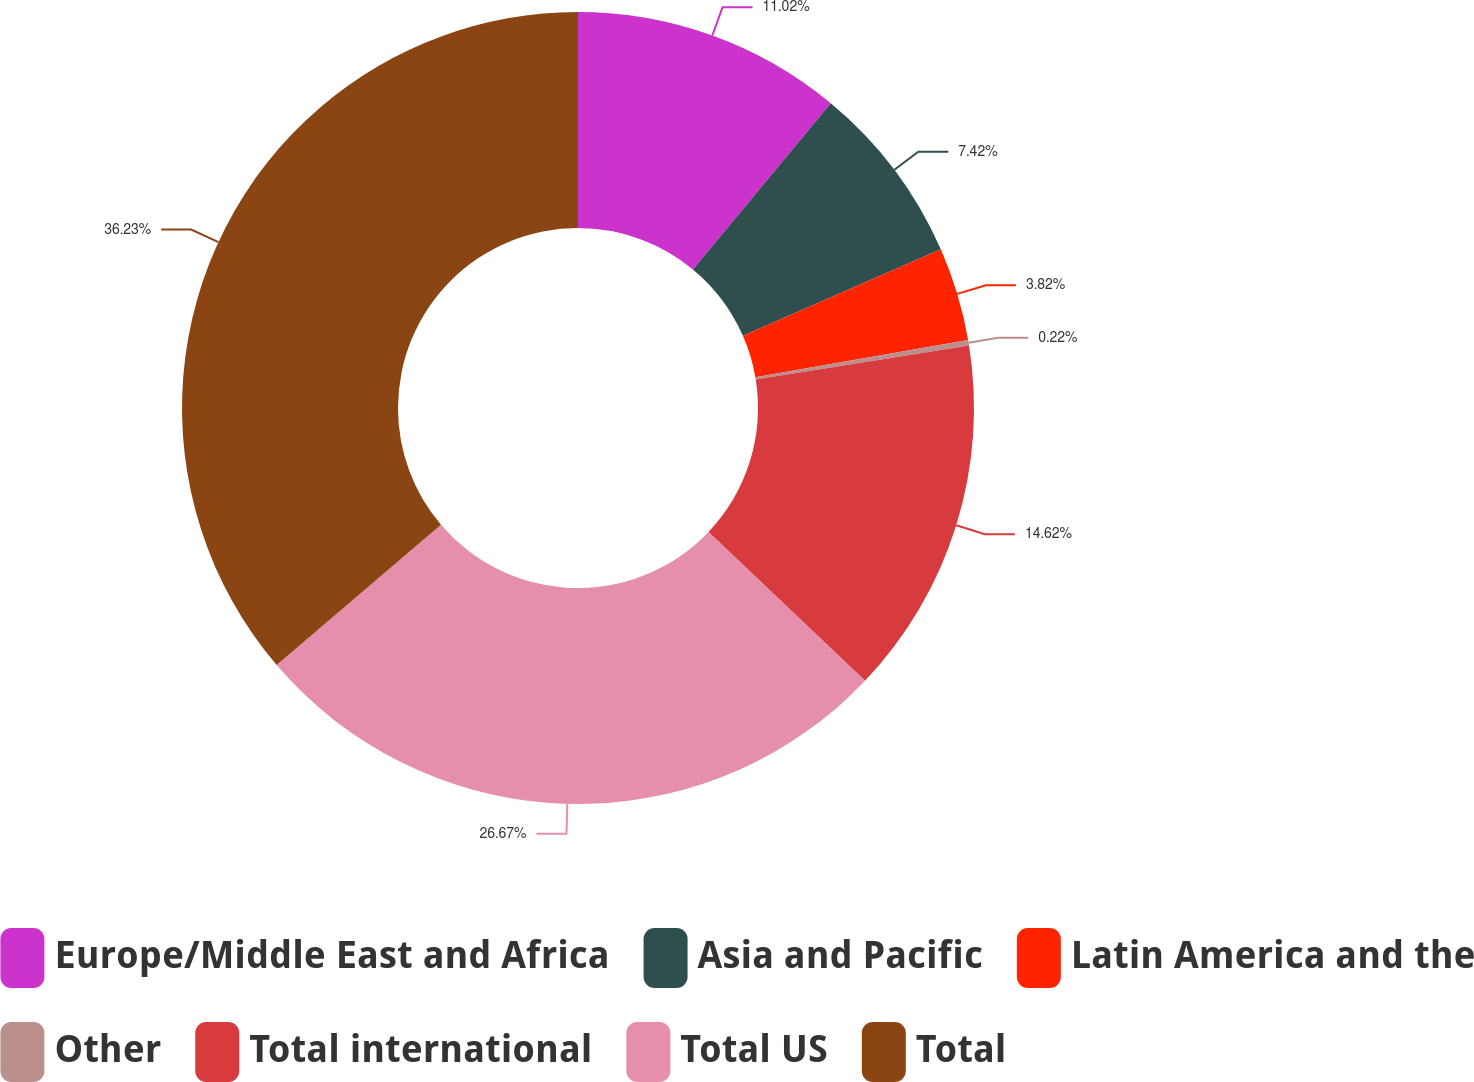<chart> <loc_0><loc_0><loc_500><loc_500><pie_chart><fcel>Europe/Middle East and Africa<fcel>Asia and Pacific<fcel>Latin America and the<fcel>Other<fcel>Total international<fcel>Total US<fcel>Total<nl><fcel>11.02%<fcel>7.42%<fcel>3.82%<fcel>0.22%<fcel>14.62%<fcel>26.67%<fcel>36.24%<nl></chart> 